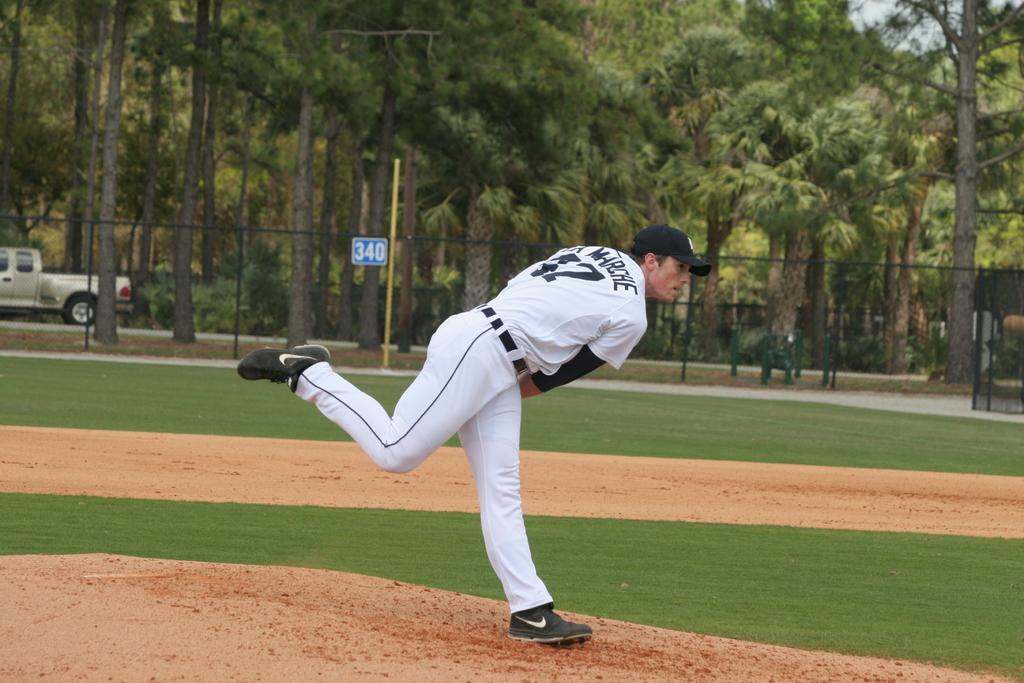<image>
Give a short and clear explanation of the subsequent image. A pitcher named Marche is perched on the mound seemingly just having thrown the ball. 